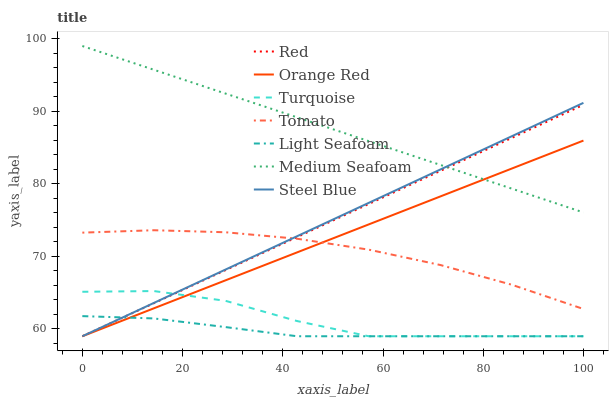Does Turquoise have the minimum area under the curve?
Answer yes or no. No. Does Turquoise have the maximum area under the curve?
Answer yes or no. No. Is Turquoise the smoothest?
Answer yes or no. No. Is Steel Blue the roughest?
Answer yes or no. No. Does Medium Seafoam have the lowest value?
Answer yes or no. No. Does Turquoise have the highest value?
Answer yes or no. No. Is Light Seafoam less than Medium Seafoam?
Answer yes or no. Yes. Is Tomato greater than Turquoise?
Answer yes or no. Yes. Does Light Seafoam intersect Medium Seafoam?
Answer yes or no. No. 